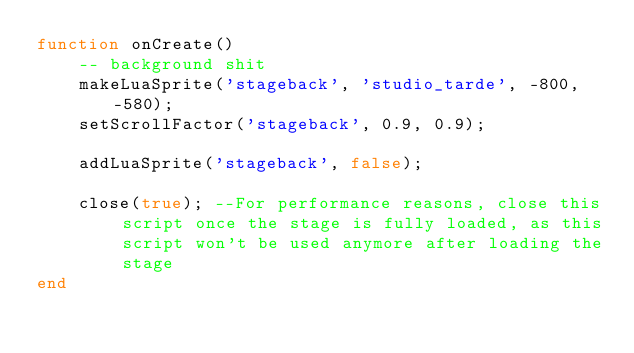<code> <loc_0><loc_0><loc_500><loc_500><_Lua_>function onCreate()
	-- background shit
	makeLuaSprite('stageback', 'studio_tarde', -800, -580);
	setScrollFactor('stageback', 0.9, 0.9);
	
	addLuaSprite('stageback', false);
	
	close(true); --For performance reasons, close this script once the stage is fully loaded, as this script won't be used anymore after loading the stage
end</code> 